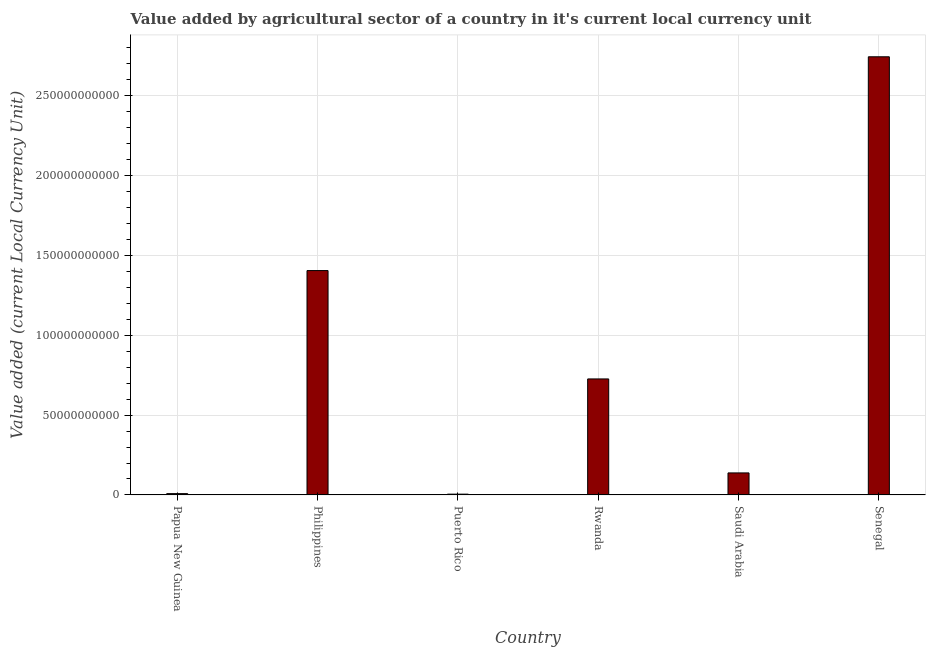Does the graph contain any zero values?
Keep it short and to the point. No. What is the title of the graph?
Your answer should be very brief. Value added by agricultural sector of a country in it's current local currency unit. What is the label or title of the Y-axis?
Your answer should be compact. Value added (current Local Currency Unit). What is the value added by agriculture sector in Saudi Arabia?
Ensure brevity in your answer.  1.38e+1. Across all countries, what is the maximum value added by agriculture sector?
Give a very brief answer. 2.74e+11. Across all countries, what is the minimum value added by agriculture sector?
Your answer should be very brief. 4.94e+08. In which country was the value added by agriculture sector maximum?
Make the answer very short. Senegal. In which country was the value added by agriculture sector minimum?
Make the answer very short. Puerto Rico. What is the sum of the value added by agriculture sector?
Offer a very short reply. 5.03e+11. What is the difference between the value added by agriculture sector in Papua New Guinea and Senegal?
Make the answer very short. -2.74e+11. What is the average value added by agriculture sector per country?
Ensure brevity in your answer.  8.38e+1. What is the median value added by agriculture sector?
Offer a terse response. 4.32e+1. What is the ratio of the value added by agriculture sector in Puerto Rico to that in Rwanda?
Provide a short and direct response. 0.01. What is the difference between the highest and the second highest value added by agriculture sector?
Give a very brief answer. 1.34e+11. What is the difference between the highest and the lowest value added by agriculture sector?
Give a very brief answer. 2.74e+11. Are all the bars in the graph horizontal?
Your response must be concise. No. How many countries are there in the graph?
Keep it short and to the point. 6. What is the difference between two consecutive major ticks on the Y-axis?
Your answer should be very brief. 5.00e+1. Are the values on the major ticks of Y-axis written in scientific E-notation?
Your response must be concise. No. What is the Value added (current Local Currency Unit) of Papua New Guinea?
Make the answer very short. 8.19e+08. What is the Value added (current Local Currency Unit) of Philippines?
Provide a succinct answer. 1.41e+11. What is the Value added (current Local Currency Unit) of Puerto Rico?
Your response must be concise. 4.94e+08. What is the Value added (current Local Currency Unit) in Rwanda?
Offer a terse response. 7.27e+1. What is the Value added (current Local Currency Unit) in Saudi Arabia?
Ensure brevity in your answer.  1.38e+1. What is the Value added (current Local Currency Unit) of Senegal?
Your response must be concise. 2.74e+11. What is the difference between the Value added (current Local Currency Unit) in Papua New Guinea and Philippines?
Your response must be concise. -1.40e+11. What is the difference between the Value added (current Local Currency Unit) in Papua New Guinea and Puerto Rico?
Your response must be concise. 3.24e+08. What is the difference between the Value added (current Local Currency Unit) in Papua New Guinea and Rwanda?
Provide a succinct answer. -7.18e+1. What is the difference between the Value added (current Local Currency Unit) in Papua New Guinea and Saudi Arabia?
Your answer should be compact. -1.30e+1. What is the difference between the Value added (current Local Currency Unit) in Papua New Guinea and Senegal?
Your response must be concise. -2.74e+11. What is the difference between the Value added (current Local Currency Unit) in Philippines and Puerto Rico?
Give a very brief answer. 1.40e+11. What is the difference between the Value added (current Local Currency Unit) in Philippines and Rwanda?
Ensure brevity in your answer.  6.79e+1. What is the difference between the Value added (current Local Currency Unit) in Philippines and Saudi Arabia?
Keep it short and to the point. 1.27e+11. What is the difference between the Value added (current Local Currency Unit) in Philippines and Senegal?
Provide a short and direct response. -1.34e+11. What is the difference between the Value added (current Local Currency Unit) in Puerto Rico and Rwanda?
Provide a short and direct response. -7.22e+1. What is the difference between the Value added (current Local Currency Unit) in Puerto Rico and Saudi Arabia?
Your answer should be compact. -1.33e+1. What is the difference between the Value added (current Local Currency Unit) in Puerto Rico and Senegal?
Your answer should be very brief. -2.74e+11. What is the difference between the Value added (current Local Currency Unit) in Rwanda and Saudi Arabia?
Your response must be concise. 5.89e+1. What is the difference between the Value added (current Local Currency Unit) in Rwanda and Senegal?
Provide a short and direct response. -2.02e+11. What is the difference between the Value added (current Local Currency Unit) in Saudi Arabia and Senegal?
Offer a terse response. -2.61e+11. What is the ratio of the Value added (current Local Currency Unit) in Papua New Guinea to that in Philippines?
Your response must be concise. 0.01. What is the ratio of the Value added (current Local Currency Unit) in Papua New Guinea to that in Puerto Rico?
Keep it short and to the point. 1.66. What is the ratio of the Value added (current Local Currency Unit) in Papua New Guinea to that in Rwanda?
Your response must be concise. 0.01. What is the ratio of the Value added (current Local Currency Unit) in Papua New Guinea to that in Saudi Arabia?
Your answer should be compact. 0.06. What is the ratio of the Value added (current Local Currency Unit) in Papua New Guinea to that in Senegal?
Your answer should be very brief. 0. What is the ratio of the Value added (current Local Currency Unit) in Philippines to that in Puerto Rico?
Your response must be concise. 284.31. What is the ratio of the Value added (current Local Currency Unit) in Philippines to that in Rwanda?
Make the answer very short. 1.93. What is the ratio of the Value added (current Local Currency Unit) in Philippines to that in Saudi Arabia?
Provide a succinct answer. 10.19. What is the ratio of the Value added (current Local Currency Unit) in Philippines to that in Senegal?
Provide a short and direct response. 0.51. What is the ratio of the Value added (current Local Currency Unit) in Puerto Rico to that in Rwanda?
Your response must be concise. 0.01. What is the ratio of the Value added (current Local Currency Unit) in Puerto Rico to that in Saudi Arabia?
Provide a short and direct response. 0.04. What is the ratio of the Value added (current Local Currency Unit) in Puerto Rico to that in Senegal?
Provide a succinct answer. 0. What is the ratio of the Value added (current Local Currency Unit) in Rwanda to that in Saudi Arabia?
Offer a very short reply. 5.27. What is the ratio of the Value added (current Local Currency Unit) in Rwanda to that in Senegal?
Provide a succinct answer. 0.27. What is the ratio of the Value added (current Local Currency Unit) in Saudi Arabia to that in Senegal?
Keep it short and to the point. 0.05. 